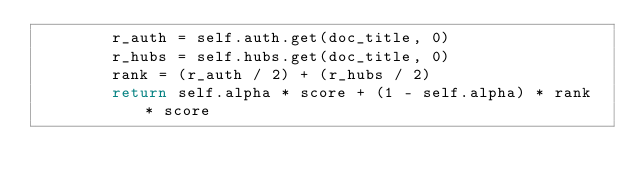Convert code to text. <code><loc_0><loc_0><loc_500><loc_500><_Python_>        r_auth = self.auth.get(doc_title, 0)
        r_hubs = self.hubs.get(doc_title, 0)
        rank = (r_auth / 2) + (r_hubs / 2)
        return self.alpha * score + (1 - self.alpha) * rank * score
</code> 